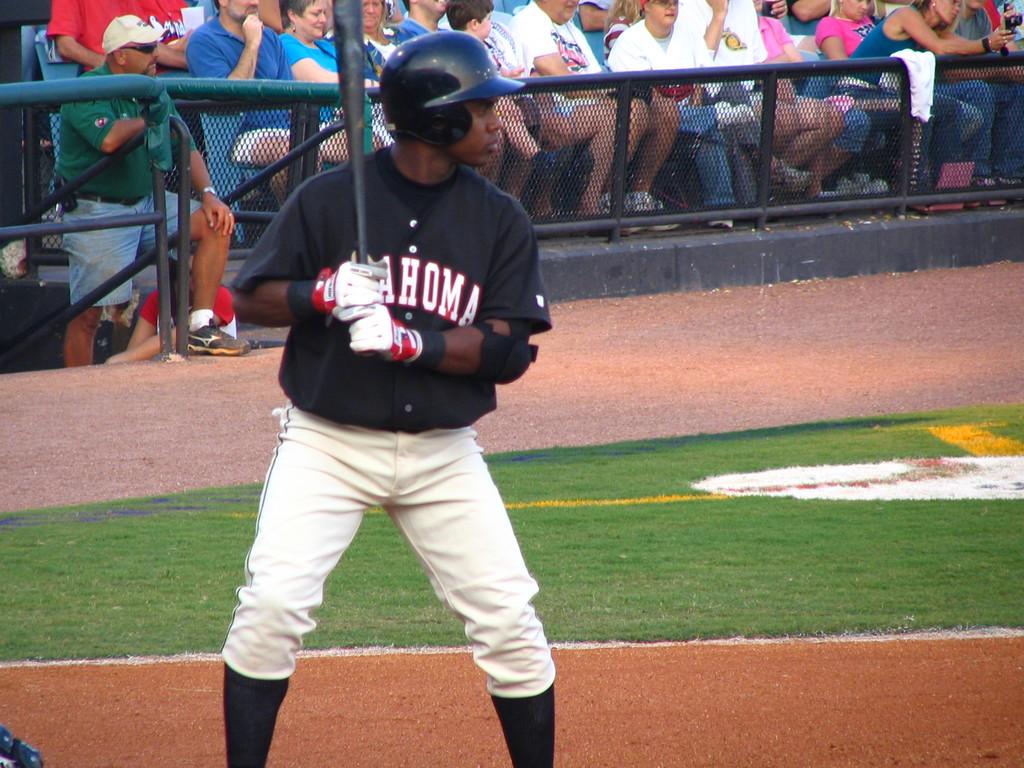Does this man play ball for oklahoma?
Keep it short and to the point. Yes. 